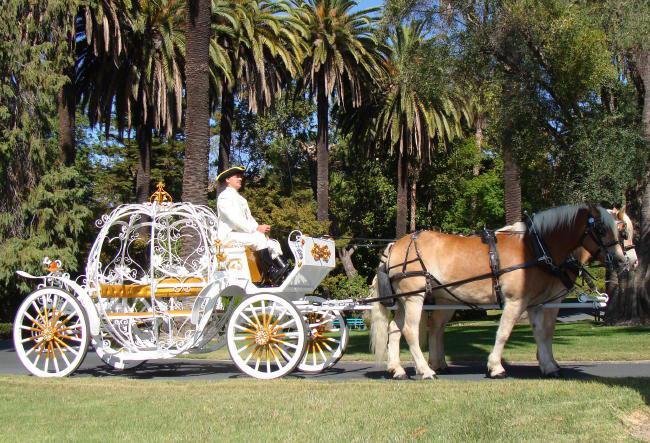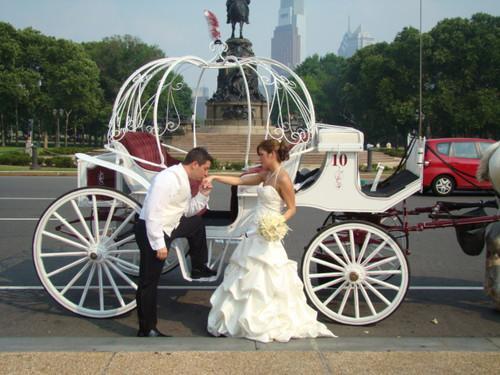The first image is the image on the left, the second image is the image on the right. Considering the images on both sides, is "The left image shows a carriage pulled by a brown horse." valid? Answer yes or no. Yes. 